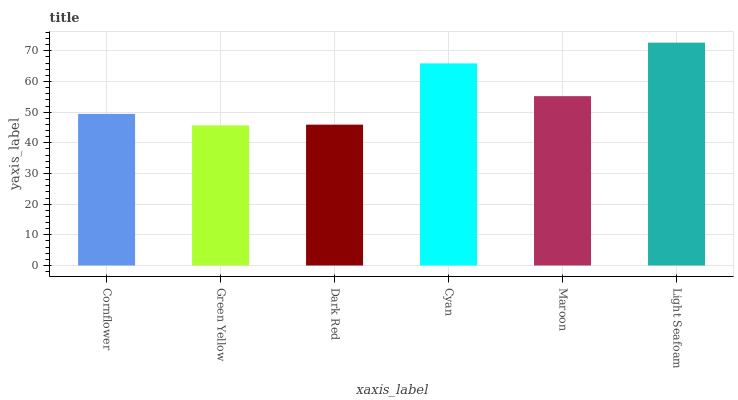Is Dark Red the minimum?
Answer yes or no. No. Is Dark Red the maximum?
Answer yes or no. No. Is Dark Red greater than Green Yellow?
Answer yes or no. Yes. Is Green Yellow less than Dark Red?
Answer yes or no. Yes. Is Green Yellow greater than Dark Red?
Answer yes or no. No. Is Dark Red less than Green Yellow?
Answer yes or no. No. Is Maroon the high median?
Answer yes or no. Yes. Is Cornflower the low median?
Answer yes or no. Yes. Is Green Yellow the high median?
Answer yes or no. No. Is Maroon the low median?
Answer yes or no. No. 